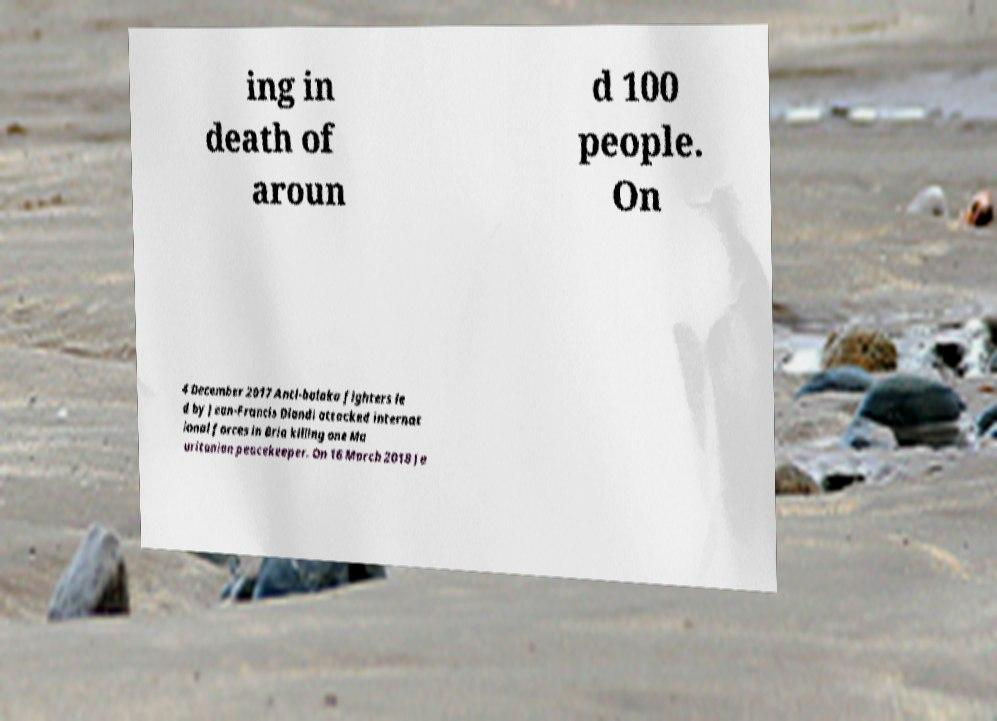I need the written content from this picture converted into text. Can you do that? ing in death of aroun d 100 people. On 4 December 2017 Anti-balaka fighters le d by Jean-Francis Diandi attacked internat ional forces in Bria killing one Ma uritanian peacekeeper. On 16 March 2018 Je 